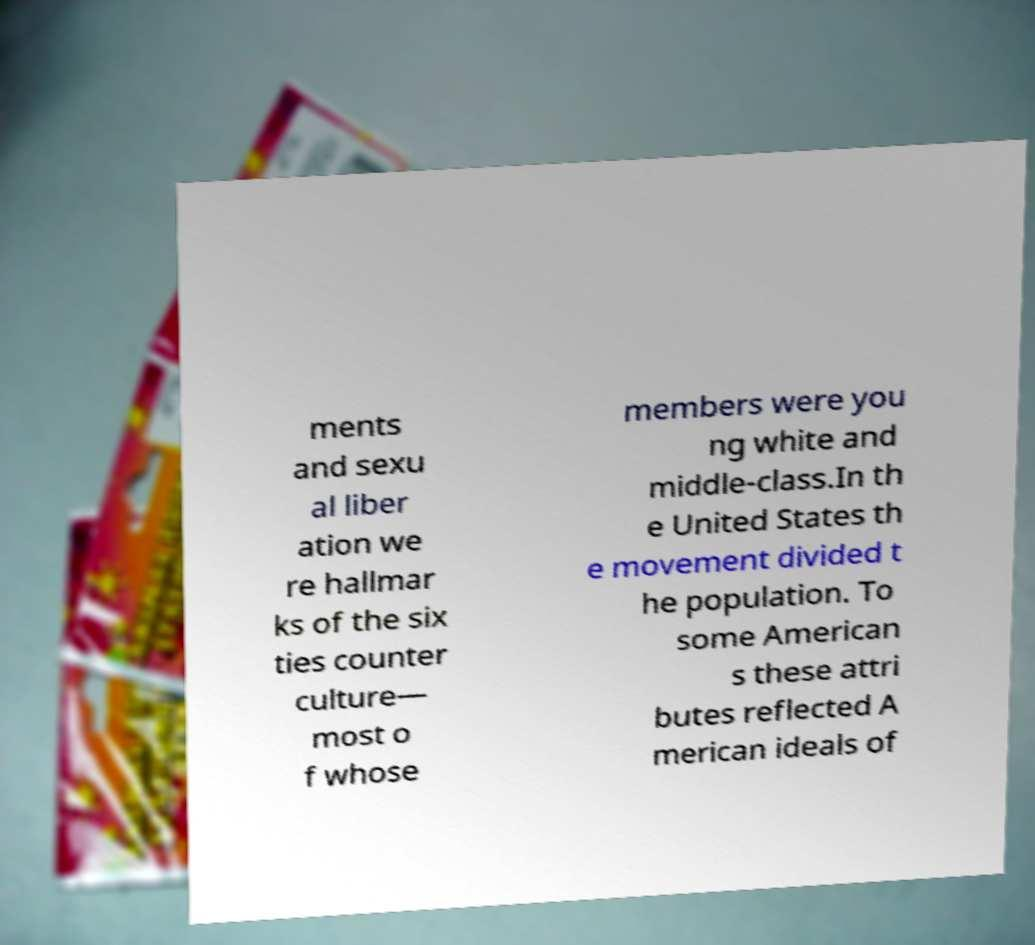There's text embedded in this image that I need extracted. Can you transcribe it verbatim? ments and sexu al liber ation we re hallmar ks of the six ties counter culture— most o f whose members were you ng white and middle-class.In th e United States th e movement divided t he population. To some American s these attri butes reflected A merican ideals of 